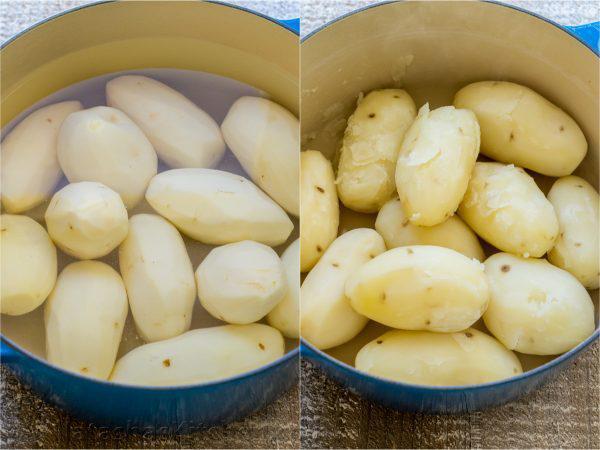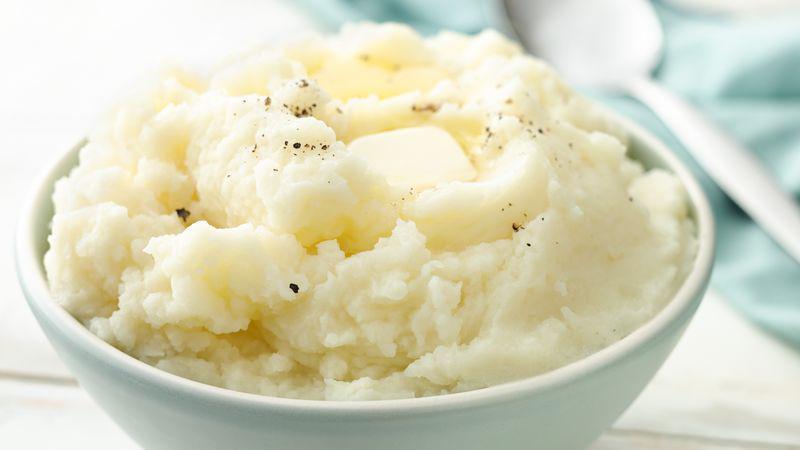The first image is the image on the left, the second image is the image on the right. Given the left and right images, does the statement "One image shows potatoes in a pot of water before boiling." hold true? Answer yes or no. Yes. 